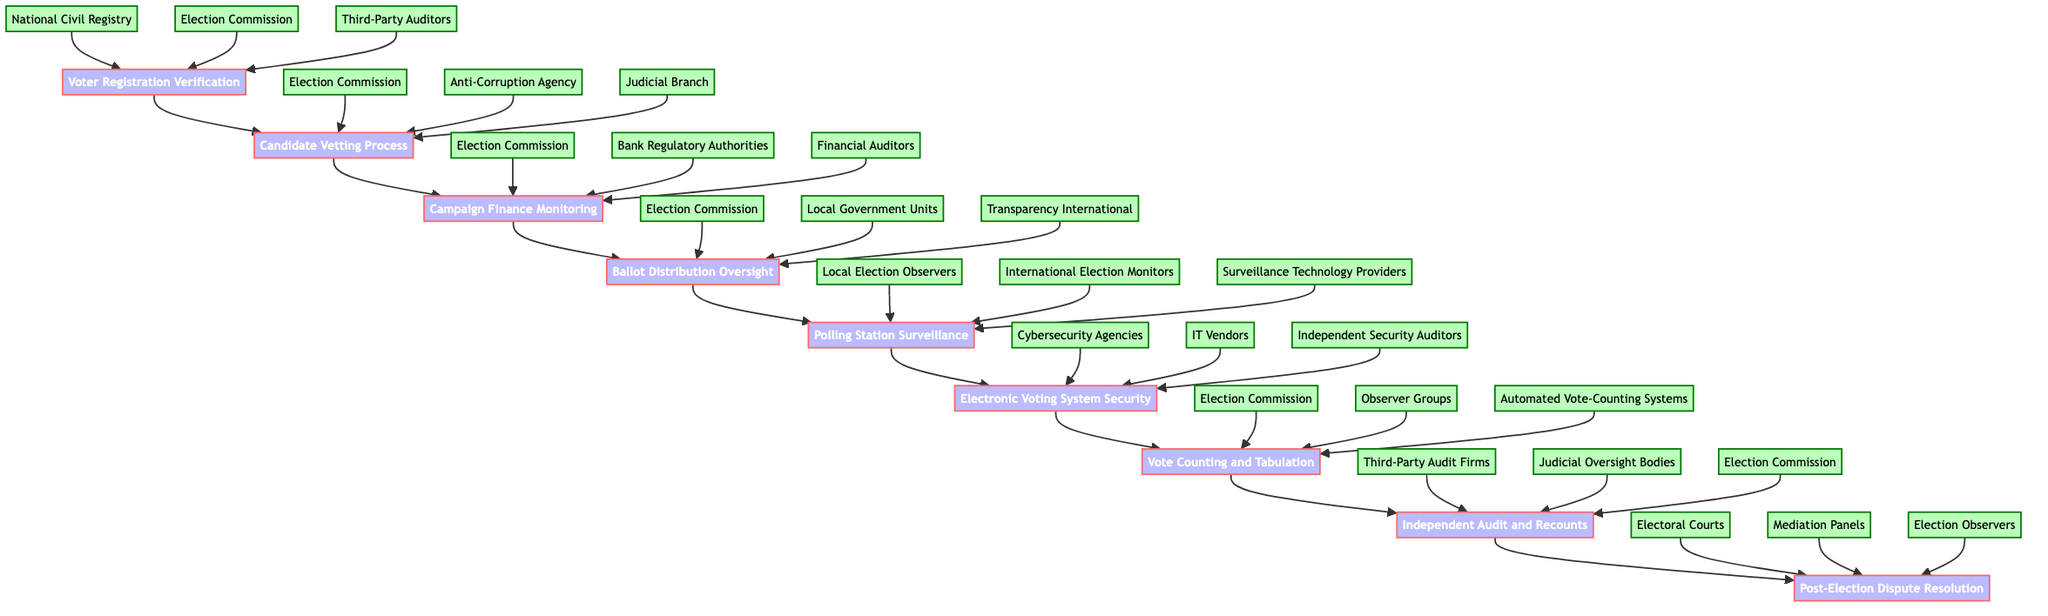What is the first step in the election monitoring process? The diagram shows that the first step in the election monitoring process is "Voter Registration Verification." This is illustrated by the start node leading to the first function in the flowchart.
Answer: Voter Registration Verification How many entities are involved in the Candidate Vetting Process? The Candidate Vetting Process has three entities connected to it: "Election Commission," "Anti-Corruption Agency," and "Judicial Branch." This can be counted by looking at the connections coming into the Candidate Vetting Process node.
Answer: 3 What process follows Ballot Distribution Oversight? According to the flowchart, the process that follows Ballot Distribution Oversight is "Polling Station Surveillance." This relationship is shown by the arrow leading from the Ballot Distribution Oversight node to the Polling Station Surveillance node.
Answer: Polling Station Surveillance Who is involved in the Vote Counting and Tabulation process? The Vote Counting and Tabulation process is supported by three entities: "Election Commission," "Observer Groups," and "Automated Vote-Counting Systems." By examining the connections, these entities can be identified as contributing to this function.
Answer: Election Commission, Observer Groups, Automated Vote-Counting Systems What is the last function in the election monitoring flow? The last function indicated in the election monitoring flow is "Post-Election Dispute Resolution." This is the endpoint of the flowchart, which indicates the final step in the process.
Answer: Post-Election Dispute Resolution Which entities are associated with Electronic Voting System Security? The entities associated with Electronic Voting System Security are "Cybersecurity Agencies," "IT Vendors," and "Independent Security Auditors." These entities' connections to the Electronic Voting System Security node can be viewed in the diagram.
Answer: Cybersecurity Agencies, IT Vendors, Independent Security Auditors How many total processes are there in the election monitoring flowchart? There are eight processes in total within the election monitoring flowchart. This can be determined by counting the individual process nodes present in the diagram, from Voter Registration Verification to Post-Election Dispute Resolution.
Answer: 8 What is the relation between Candidate Vetting Process and Campaign Finance Monitoring? The Candidate Vetting Process is followed directly by the Campaign Finance Monitoring process, indicating a sequential relationship in the election monitoring flow. This is represented by the connecting arrow from Candidate Vetting Process to Campaign Finance Monitoring.
Answer: Directly follows 